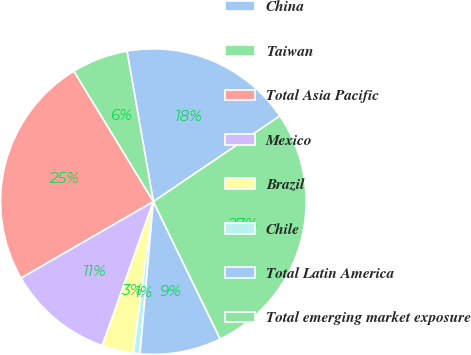Convert chart to OTSL. <chart><loc_0><loc_0><loc_500><loc_500><pie_chart><fcel>China<fcel>Taiwan<fcel>Total Asia Pacific<fcel>Mexico<fcel>Brazil<fcel>Chile<fcel>Total Latin America<fcel>Total emerging market exposure<nl><fcel>18.29%<fcel>5.96%<fcel>24.63%<fcel>11.23%<fcel>3.33%<fcel>0.7%<fcel>8.6%<fcel>27.26%<nl></chart> 